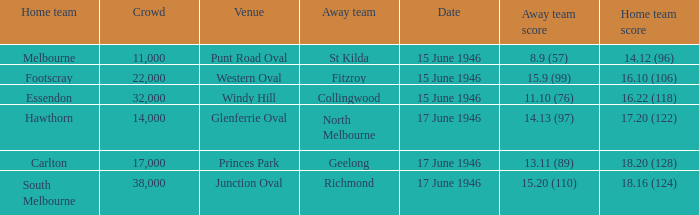Which home team has a home team 14.12 (96)? Melbourne. Would you be able to parse every entry in this table? {'header': ['Home team', 'Crowd', 'Venue', 'Away team', 'Date', 'Away team score', 'Home team score'], 'rows': [['Melbourne', '11,000', 'Punt Road Oval', 'St Kilda', '15 June 1946', '8.9 (57)', '14.12 (96)'], ['Footscray', '22,000', 'Western Oval', 'Fitzroy', '15 June 1946', '15.9 (99)', '16.10 (106)'], ['Essendon', '32,000', 'Windy Hill', 'Collingwood', '15 June 1946', '11.10 (76)', '16.22 (118)'], ['Hawthorn', '14,000', 'Glenferrie Oval', 'North Melbourne', '17 June 1946', '14.13 (97)', '17.20 (122)'], ['Carlton', '17,000', 'Princes Park', 'Geelong', '17 June 1946', '13.11 (89)', '18.20 (128)'], ['South Melbourne', '38,000', 'Junction Oval', 'Richmond', '17 June 1946', '15.20 (110)', '18.16 (124)']]} 